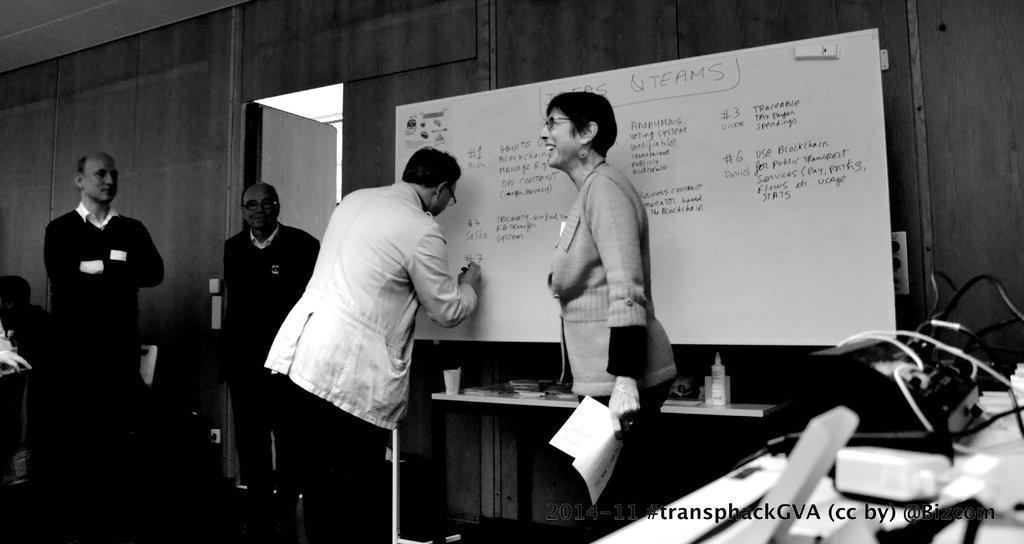Please provide a concise description of this image. In this picture there is a person standing and writing and there is a woman standing and smiling and she is holding the paper. At the back there is a person sitting and there are two persons standing. On the right side of the image there are devices and wires on the table. At the back there is text on the board and there is glass and bottle and objects on the table. On the left side of the image there is a door and there are chairs and there is a switch board and there are objects on the wall. At the bottom right there is text. 